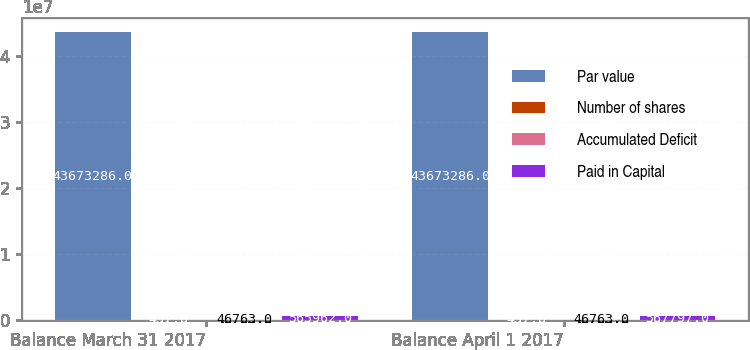Convert chart. <chart><loc_0><loc_0><loc_500><loc_500><stacked_bar_chart><ecel><fcel>Balance March 31 2017<fcel>Balance April 1 2017<nl><fcel>Par value<fcel>4.36733e+07<fcel>4.36733e+07<nl><fcel>Number of shares<fcel>437<fcel>437<nl><fcel>Accumulated Deficit<fcel>46763<fcel>46763<nl><fcel>Paid in Capital<fcel>565962<fcel>567797<nl></chart> 